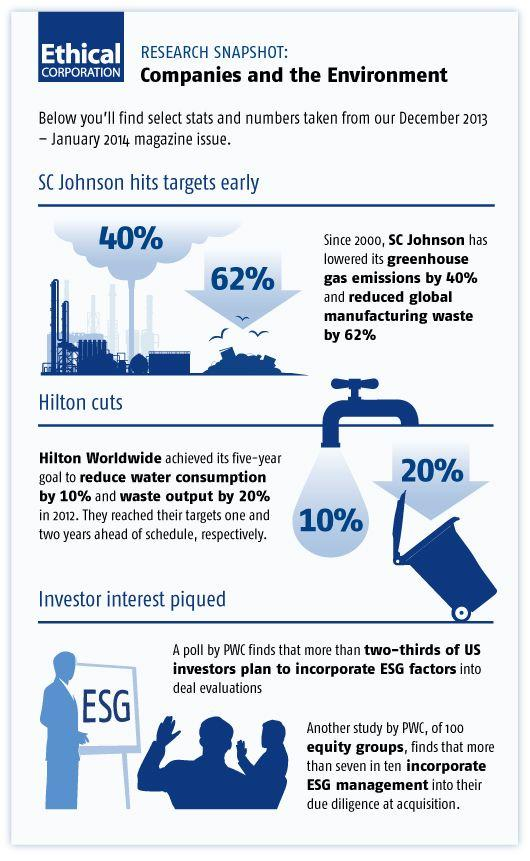Highlight a few significant elements in this photo. What is written on the board? ESG is written on the board. 